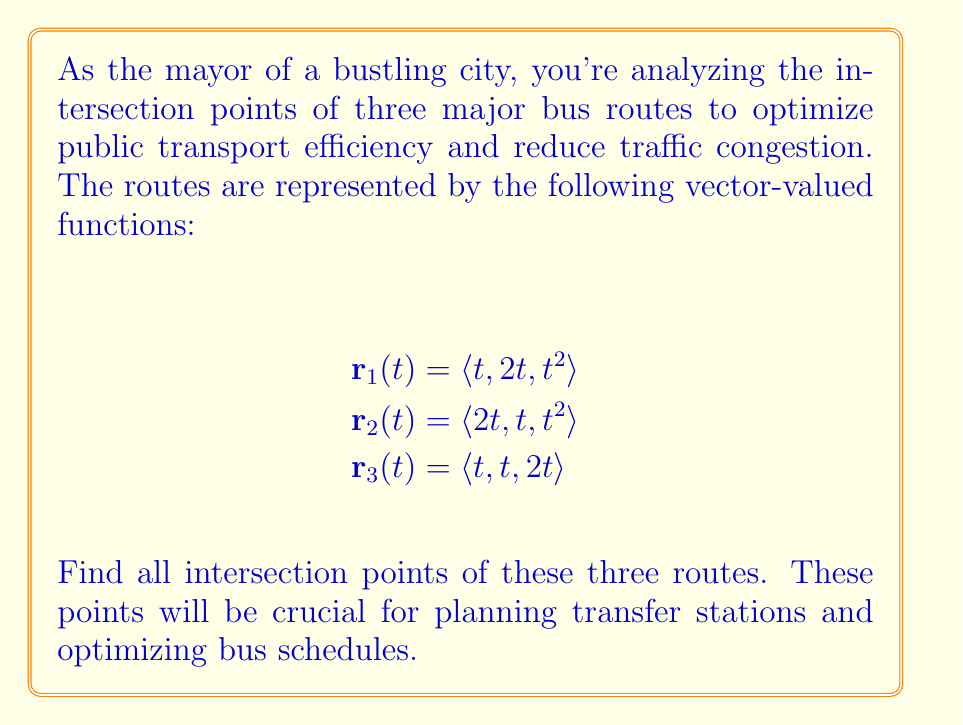Can you solve this math problem? To find the intersection points, we need to equate the vector components of each pair of routes and solve the resulting systems of equations.

1) First, let's find intersections between $\mathbf{r}_1$ and $\mathbf{r}_2$:

   $$t = 2t, 2t = t, t^2 = t^2$$

   From the first equation: $t = 2t \implies t = 0$
   This satisfies all equations, giving the point (0,0,0).

2) Now, let's find intersections between $\mathbf{r}_1$ and $\mathbf{r}_3$:

   $$t = t, 2t = t, t^2 = 2t$$

   From the second equation: $2t = t \implies t = 0$ or $t = 1$
   For $t = 0$, we get (0,0,0)
   For $t = 1$, we get (1,2,1), but this doesn't satisfy $t^2 = 2t$
   So the only intersection is (0,0,0)

3) Finally, let's find intersections between $\mathbf{r}_2$ and $\mathbf{r}_3$:

   $$2t = t, t = t, t^2 = 2t$$

   From the first equation: $2t = t \implies t = 0$ or $t = 1$
   For $t = 0$, we get (0,0,0)
   For $t = 1$, we get (2,1,1), but this doesn't satisfy $t^2 = 2t$
   So the only intersection is (0,0,0)

4) To find if there's a point where all three routes intersect, we solve:

   $$t = 2t = t, 2t = t = t, t^2 = t^2 = 2t$$

   This gives us $t = 0$ (point (0,0,0)) and $t = 2$ (point (2,2,2))

Therefore, all three routes intersect at two points: (0,0,0) and (2,2,2).
Answer: (0,0,0) and (2,2,2) 